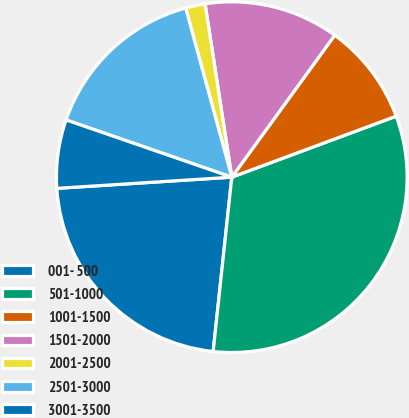Convert chart. <chart><loc_0><loc_0><loc_500><loc_500><pie_chart><fcel>001- 500<fcel>501-1000<fcel>1001-1500<fcel>1501-2000<fcel>2001-2500<fcel>2501-3000<fcel>3001-3500<nl><fcel>22.29%<fcel>32.35%<fcel>9.36%<fcel>12.42%<fcel>1.8%<fcel>15.47%<fcel>6.31%<nl></chart> 